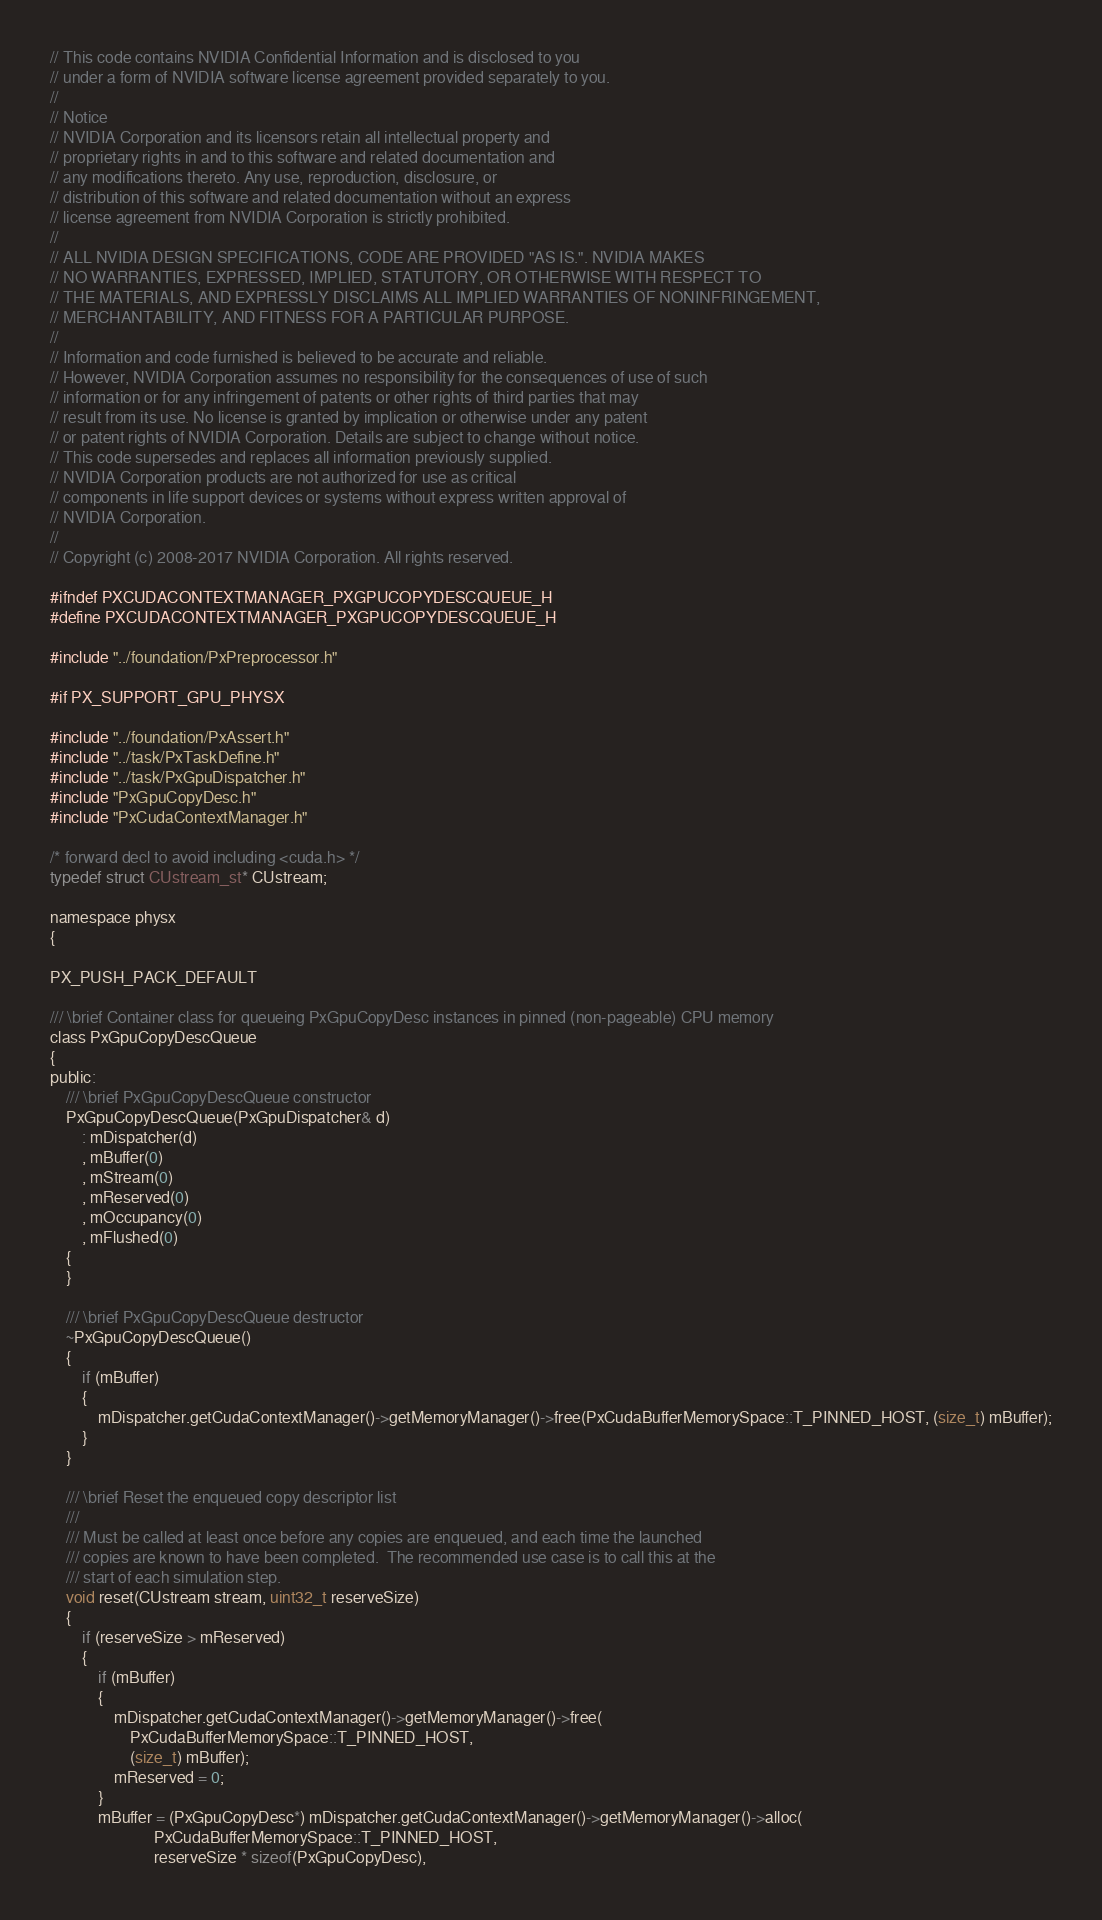Convert code to text. <code><loc_0><loc_0><loc_500><loc_500><_C_>// This code contains NVIDIA Confidential Information and is disclosed to you
// under a form of NVIDIA software license agreement provided separately to you.
//
// Notice
// NVIDIA Corporation and its licensors retain all intellectual property and
// proprietary rights in and to this software and related documentation and
// any modifications thereto. Any use, reproduction, disclosure, or
// distribution of this software and related documentation without an express
// license agreement from NVIDIA Corporation is strictly prohibited.
//
// ALL NVIDIA DESIGN SPECIFICATIONS, CODE ARE PROVIDED "AS IS.". NVIDIA MAKES
// NO WARRANTIES, EXPRESSED, IMPLIED, STATUTORY, OR OTHERWISE WITH RESPECT TO
// THE MATERIALS, AND EXPRESSLY DISCLAIMS ALL IMPLIED WARRANTIES OF NONINFRINGEMENT,
// MERCHANTABILITY, AND FITNESS FOR A PARTICULAR PURPOSE.
//
// Information and code furnished is believed to be accurate and reliable.
// However, NVIDIA Corporation assumes no responsibility for the consequences of use of such
// information or for any infringement of patents or other rights of third parties that may
// result from its use. No license is granted by implication or otherwise under any patent
// or patent rights of NVIDIA Corporation. Details are subject to change without notice.
// This code supersedes and replaces all information previously supplied.
// NVIDIA Corporation products are not authorized for use as critical
// components in life support devices or systems without express written approval of
// NVIDIA Corporation.
//
// Copyright (c) 2008-2017 NVIDIA Corporation. All rights reserved.

#ifndef PXCUDACONTEXTMANAGER_PXGPUCOPYDESCQUEUE_H
#define PXCUDACONTEXTMANAGER_PXGPUCOPYDESCQUEUE_H

#include "../foundation/PxPreprocessor.h"

#if PX_SUPPORT_GPU_PHYSX

#include "../foundation/PxAssert.h"
#include "../task/PxTaskDefine.h"
#include "../task/PxGpuDispatcher.h"
#include "PxGpuCopyDesc.h"
#include "PxCudaContextManager.h"

/* forward decl to avoid including <cuda.h> */
typedef struct CUstream_st* CUstream;

namespace physx
{

PX_PUSH_PACK_DEFAULT

/// \brief Container class for queueing PxGpuCopyDesc instances in pinned (non-pageable) CPU memory
class PxGpuCopyDescQueue
{
public:
	/// \brief PxGpuCopyDescQueue constructor
	PxGpuCopyDescQueue(PxGpuDispatcher& d)
		: mDispatcher(d)
		, mBuffer(0)
		, mStream(0)
		, mReserved(0)
		, mOccupancy(0)
		, mFlushed(0)
	{
	}

	/// \brief PxGpuCopyDescQueue destructor
	~PxGpuCopyDescQueue()
	{
		if (mBuffer)
		{
			mDispatcher.getCudaContextManager()->getMemoryManager()->free(PxCudaBufferMemorySpace::T_PINNED_HOST, (size_t) mBuffer);
		}
	}

	/// \brief Reset the enqueued copy descriptor list
	///
	/// Must be called at least once before any copies are enqueued, and each time the launched
	/// copies are known to have been completed.  The recommended use case is to call this at the
	/// start of each simulation step.
	void reset(CUstream stream, uint32_t reserveSize)
	{
		if (reserveSize > mReserved)
		{
			if (mBuffer)
			{
				mDispatcher.getCudaContextManager()->getMemoryManager()->free(
				    PxCudaBufferMemorySpace::T_PINNED_HOST,
				    (size_t) mBuffer);
				mReserved = 0;
			}
			mBuffer = (PxGpuCopyDesc*) mDispatcher.getCudaContextManager()->getMemoryManager()->alloc(
			              PxCudaBufferMemorySpace::T_PINNED_HOST,
			              reserveSize * sizeof(PxGpuCopyDesc),</code> 